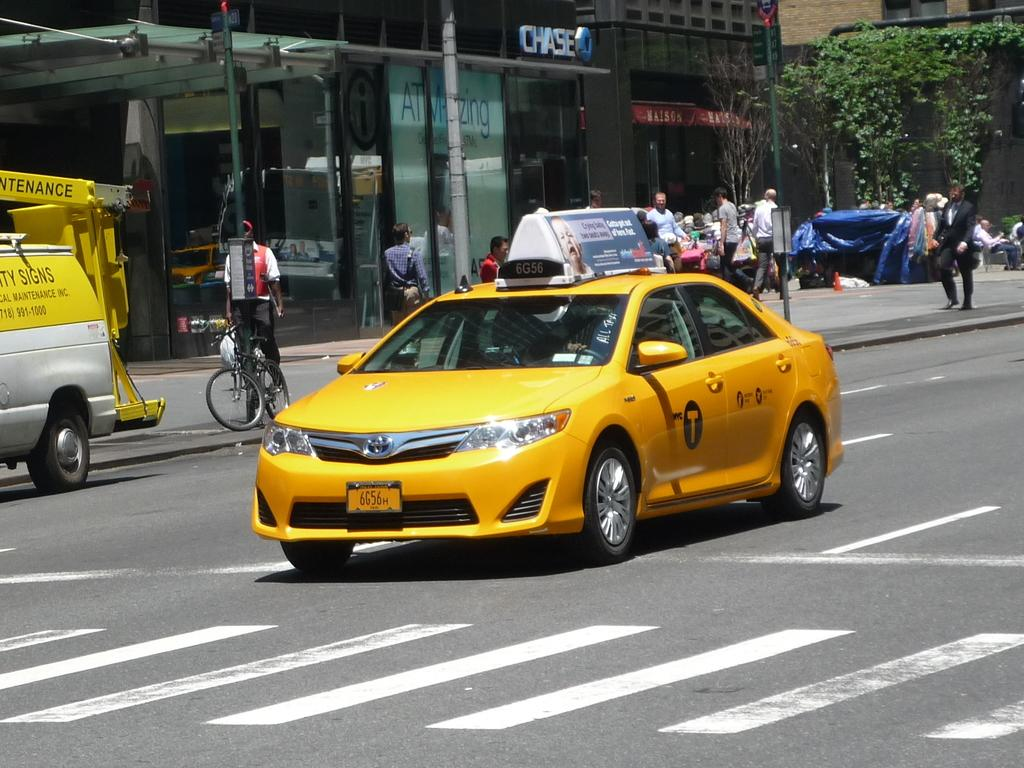<image>
Create a compact narrative representing the image presented. Taxi cab number 6G56 drives through the streets of New York City on a sunny day. 